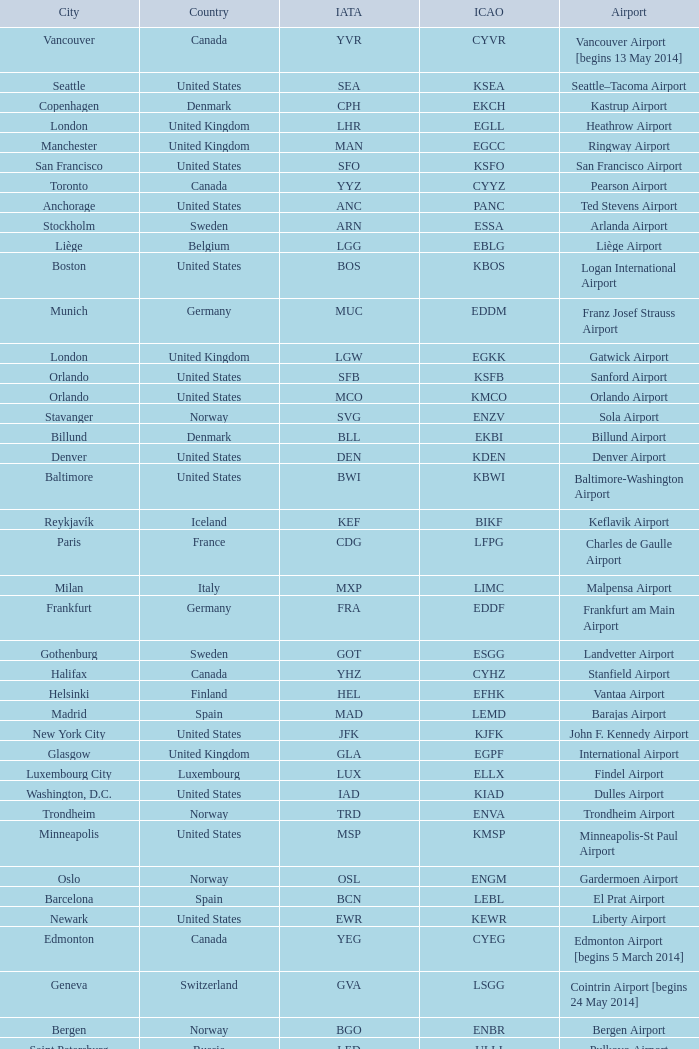What is the IATA OF Akureyri? AEY. 